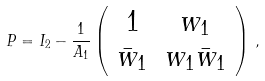Convert formula to latex. <formula><loc_0><loc_0><loc_500><loc_500>P = I _ { 2 } - \frac { 1 } { A _ { 1 } } \left ( \begin{array} { c c } 1 & w _ { 1 } \\ \bar { w } _ { 1 } & w _ { 1 } \bar { w } _ { 1 } \\ \end{array} \right ) \, ,</formula> 